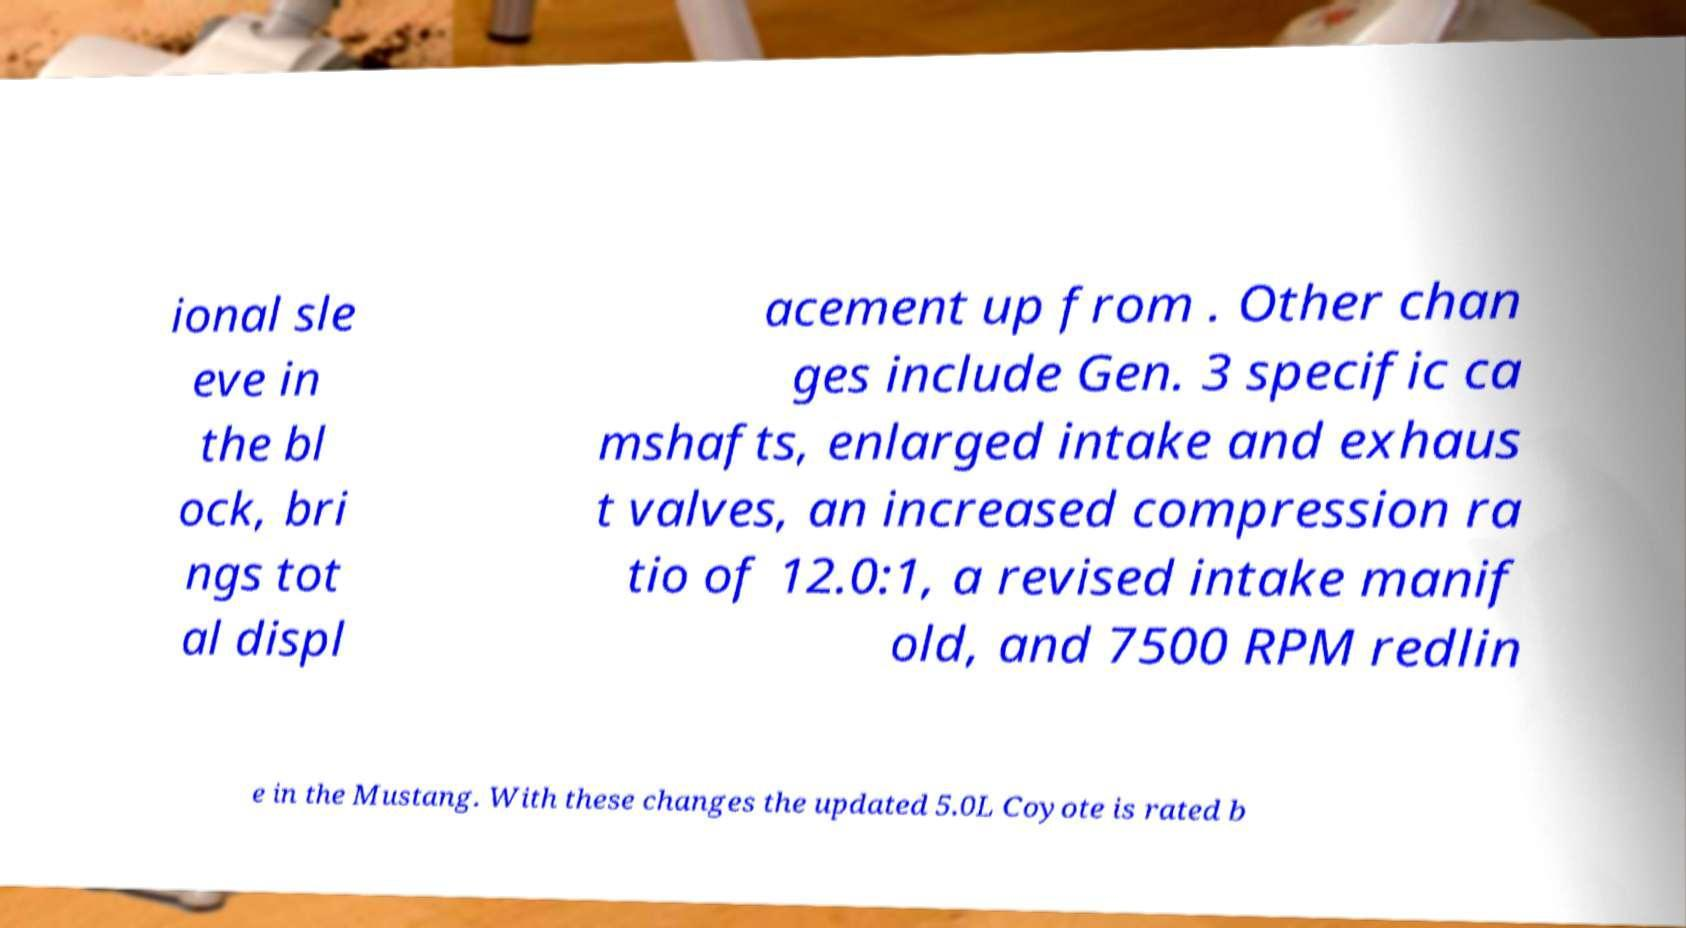Please identify and transcribe the text found in this image. ional sle eve in the bl ock, bri ngs tot al displ acement up from . Other chan ges include Gen. 3 specific ca mshafts, enlarged intake and exhaus t valves, an increased compression ra tio of 12.0:1, a revised intake manif old, and 7500 RPM redlin e in the Mustang. With these changes the updated 5.0L Coyote is rated b 